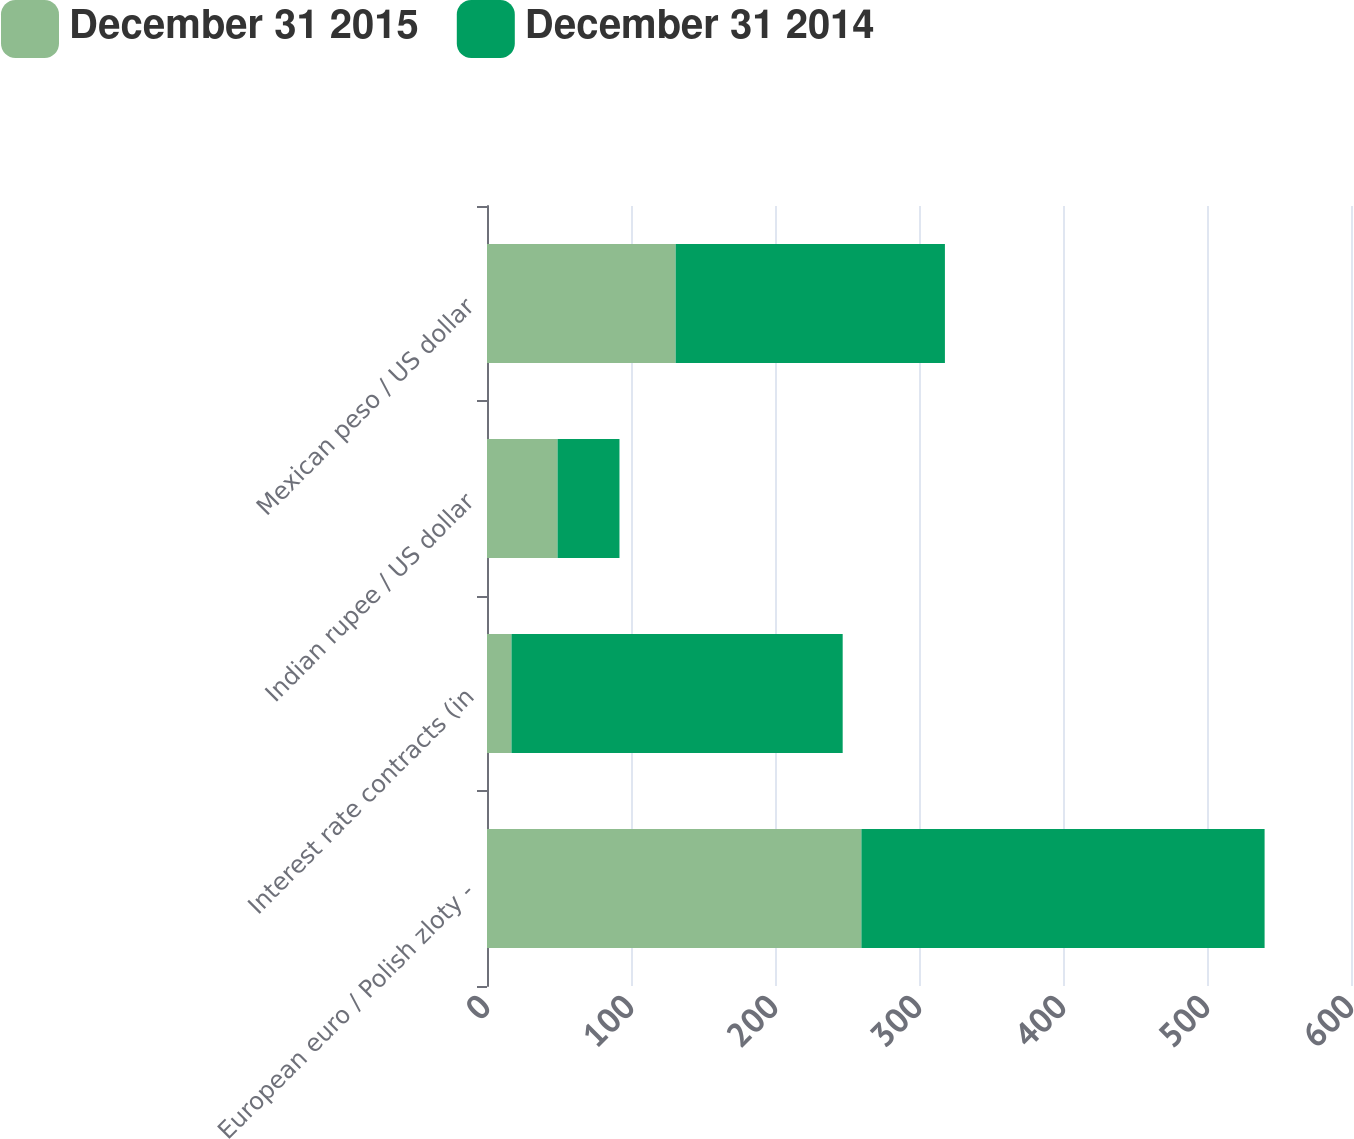<chart> <loc_0><loc_0><loc_500><loc_500><stacked_bar_chart><ecel><fcel>European euro / Polish zloty -<fcel>Interest rate contracts (in<fcel>Indian rupee / US dollar<fcel>Mexican peso / US dollar<nl><fcel>December 31 2015<fcel>260<fcel>17<fcel>49<fcel>131<nl><fcel>December 31 2014<fcel>280<fcel>230<fcel>43<fcel>187<nl></chart> 